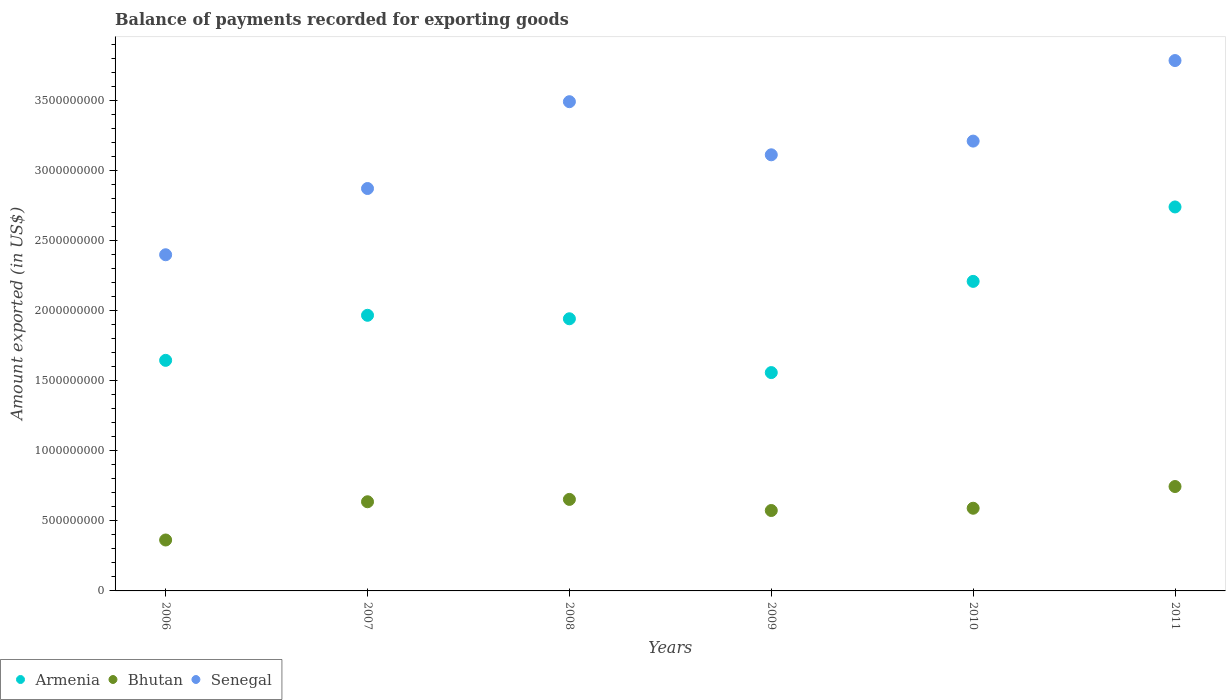How many different coloured dotlines are there?
Your answer should be very brief. 3. Is the number of dotlines equal to the number of legend labels?
Provide a short and direct response. Yes. What is the amount exported in Bhutan in 2011?
Offer a very short reply. 7.46e+08. Across all years, what is the maximum amount exported in Armenia?
Provide a succinct answer. 2.74e+09. Across all years, what is the minimum amount exported in Senegal?
Ensure brevity in your answer.  2.40e+09. What is the total amount exported in Senegal in the graph?
Offer a terse response. 1.89e+1. What is the difference between the amount exported in Bhutan in 2006 and that in 2010?
Keep it short and to the point. -2.27e+08. What is the difference between the amount exported in Senegal in 2009 and the amount exported in Armenia in 2010?
Your response must be concise. 9.04e+08. What is the average amount exported in Armenia per year?
Your response must be concise. 2.01e+09. In the year 2010, what is the difference between the amount exported in Senegal and amount exported in Bhutan?
Make the answer very short. 2.62e+09. What is the ratio of the amount exported in Bhutan in 2009 to that in 2010?
Your answer should be compact. 0.97. Is the difference between the amount exported in Senegal in 2010 and 2011 greater than the difference between the amount exported in Bhutan in 2010 and 2011?
Your answer should be very brief. No. What is the difference between the highest and the second highest amount exported in Bhutan?
Offer a very short reply. 9.19e+07. What is the difference between the highest and the lowest amount exported in Senegal?
Give a very brief answer. 1.39e+09. In how many years, is the amount exported in Bhutan greater than the average amount exported in Bhutan taken over all years?
Provide a succinct answer. 3. Is the sum of the amount exported in Armenia in 2007 and 2008 greater than the maximum amount exported in Senegal across all years?
Provide a succinct answer. Yes. Is the amount exported in Bhutan strictly greater than the amount exported in Senegal over the years?
Keep it short and to the point. No. Is the amount exported in Armenia strictly less than the amount exported in Senegal over the years?
Make the answer very short. Yes. How many dotlines are there?
Ensure brevity in your answer.  3. How many years are there in the graph?
Keep it short and to the point. 6. Does the graph contain any zero values?
Your answer should be very brief. No. Does the graph contain grids?
Your answer should be compact. No. Where does the legend appear in the graph?
Ensure brevity in your answer.  Bottom left. What is the title of the graph?
Keep it short and to the point. Balance of payments recorded for exporting goods. Does "Andorra" appear as one of the legend labels in the graph?
Your answer should be very brief. No. What is the label or title of the Y-axis?
Offer a very short reply. Amount exported (in US$). What is the Amount exported (in US$) of Armenia in 2006?
Ensure brevity in your answer.  1.65e+09. What is the Amount exported (in US$) in Bhutan in 2006?
Your answer should be compact. 3.64e+08. What is the Amount exported (in US$) of Senegal in 2006?
Your response must be concise. 2.40e+09. What is the Amount exported (in US$) of Armenia in 2007?
Make the answer very short. 1.97e+09. What is the Amount exported (in US$) in Bhutan in 2007?
Offer a very short reply. 6.37e+08. What is the Amount exported (in US$) of Senegal in 2007?
Ensure brevity in your answer.  2.87e+09. What is the Amount exported (in US$) of Armenia in 2008?
Your answer should be compact. 1.94e+09. What is the Amount exported (in US$) in Bhutan in 2008?
Ensure brevity in your answer.  6.54e+08. What is the Amount exported (in US$) in Senegal in 2008?
Your response must be concise. 3.49e+09. What is the Amount exported (in US$) of Armenia in 2009?
Provide a succinct answer. 1.56e+09. What is the Amount exported (in US$) in Bhutan in 2009?
Your response must be concise. 5.74e+08. What is the Amount exported (in US$) of Senegal in 2009?
Provide a succinct answer. 3.11e+09. What is the Amount exported (in US$) of Armenia in 2010?
Provide a short and direct response. 2.21e+09. What is the Amount exported (in US$) of Bhutan in 2010?
Your answer should be very brief. 5.90e+08. What is the Amount exported (in US$) in Senegal in 2010?
Keep it short and to the point. 3.21e+09. What is the Amount exported (in US$) in Armenia in 2011?
Give a very brief answer. 2.74e+09. What is the Amount exported (in US$) of Bhutan in 2011?
Offer a very short reply. 7.46e+08. What is the Amount exported (in US$) in Senegal in 2011?
Your response must be concise. 3.79e+09. Across all years, what is the maximum Amount exported (in US$) in Armenia?
Give a very brief answer. 2.74e+09. Across all years, what is the maximum Amount exported (in US$) of Bhutan?
Ensure brevity in your answer.  7.46e+08. Across all years, what is the maximum Amount exported (in US$) in Senegal?
Your answer should be compact. 3.79e+09. Across all years, what is the minimum Amount exported (in US$) in Armenia?
Keep it short and to the point. 1.56e+09. Across all years, what is the minimum Amount exported (in US$) of Bhutan?
Your answer should be very brief. 3.64e+08. Across all years, what is the minimum Amount exported (in US$) in Senegal?
Your response must be concise. 2.40e+09. What is the total Amount exported (in US$) of Armenia in the graph?
Provide a short and direct response. 1.21e+1. What is the total Amount exported (in US$) in Bhutan in the graph?
Provide a succinct answer. 3.56e+09. What is the total Amount exported (in US$) of Senegal in the graph?
Ensure brevity in your answer.  1.89e+1. What is the difference between the Amount exported (in US$) of Armenia in 2006 and that in 2007?
Offer a terse response. -3.22e+08. What is the difference between the Amount exported (in US$) of Bhutan in 2006 and that in 2007?
Provide a succinct answer. -2.73e+08. What is the difference between the Amount exported (in US$) in Senegal in 2006 and that in 2007?
Offer a very short reply. -4.73e+08. What is the difference between the Amount exported (in US$) of Armenia in 2006 and that in 2008?
Provide a succinct answer. -2.97e+08. What is the difference between the Amount exported (in US$) of Bhutan in 2006 and that in 2008?
Ensure brevity in your answer.  -2.90e+08. What is the difference between the Amount exported (in US$) in Senegal in 2006 and that in 2008?
Provide a short and direct response. -1.09e+09. What is the difference between the Amount exported (in US$) of Armenia in 2006 and that in 2009?
Your answer should be very brief. 8.74e+07. What is the difference between the Amount exported (in US$) of Bhutan in 2006 and that in 2009?
Offer a terse response. -2.11e+08. What is the difference between the Amount exported (in US$) in Senegal in 2006 and that in 2009?
Your answer should be very brief. -7.14e+08. What is the difference between the Amount exported (in US$) of Armenia in 2006 and that in 2010?
Your answer should be very brief. -5.64e+08. What is the difference between the Amount exported (in US$) in Bhutan in 2006 and that in 2010?
Make the answer very short. -2.27e+08. What is the difference between the Amount exported (in US$) of Senegal in 2006 and that in 2010?
Your answer should be very brief. -8.12e+08. What is the difference between the Amount exported (in US$) of Armenia in 2006 and that in 2011?
Your answer should be very brief. -1.10e+09. What is the difference between the Amount exported (in US$) of Bhutan in 2006 and that in 2011?
Give a very brief answer. -3.82e+08. What is the difference between the Amount exported (in US$) in Senegal in 2006 and that in 2011?
Your answer should be very brief. -1.39e+09. What is the difference between the Amount exported (in US$) in Armenia in 2007 and that in 2008?
Your answer should be very brief. 2.48e+07. What is the difference between the Amount exported (in US$) of Bhutan in 2007 and that in 2008?
Make the answer very short. -1.69e+07. What is the difference between the Amount exported (in US$) in Senegal in 2007 and that in 2008?
Your answer should be very brief. -6.20e+08. What is the difference between the Amount exported (in US$) in Armenia in 2007 and that in 2009?
Offer a terse response. 4.09e+08. What is the difference between the Amount exported (in US$) in Bhutan in 2007 and that in 2009?
Your response must be concise. 6.25e+07. What is the difference between the Amount exported (in US$) in Senegal in 2007 and that in 2009?
Give a very brief answer. -2.41e+08. What is the difference between the Amount exported (in US$) in Armenia in 2007 and that in 2010?
Your response must be concise. -2.42e+08. What is the difference between the Amount exported (in US$) of Bhutan in 2007 and that in 2010?
Your answer should be compact. 4.63e+07. What is the difference between the Amount exported (in US$) of Senegal in 2007 and that in 2010?
Offer a terse response. -3.39e+08. What is the difference between the Amount exported (in US$) of Armenia in 2007 and that in 2011?
Provide a succinct answer. -7.74e+08. What is the difference between the Amount exported (in US$) of Bhutan in 2007 and that in 2011?
Keep it short and to the point. -1.09e+08. What is the difference between the Amount exported (in US$) in Senegal in 2007 and that in 2011?
Provide a succinct answer. -9.14e+08. What is the difference between the Amount exported (in US$) of Armenia in 2008 and that in 2009?
Make the answer very short. 3.84e+08. What is the difference between the Amount exported (in US$) in Bhutan in 2008 and that in 2009?
Your answer should be very brief. 7.94e+07. What is the difference between the Amount exported (in US$) of Senegal in 2008 and that in 2009?
Make the answer very short. 3.79e+08. What is the difference between the Amount exported (in US$) in Armenia in 2008 and that in 2010?
Provide a short and direct response. -2.67e+08. What is the difference between the Amount exported (in US$) of Bhutan in 2008 and that in 2010?
Give a very brief answer. 6.32e+07. What is the difference between the Amount exported (in US$) of Senegal in 2008 and that in 2010?
Make the answer very short. 2.81e+08. What is the difference between the Amount exported (in US$) in Armenia in 2008 and that in 2011?
Provide a succinct answer. -7.99e+08. What is the difference between the Amount exported (in US$) in Bhutan in 2008 and that in 2011?
Provide a short and direct response. -9.19e+07. What is the difference between the Amount exported (in US$) of Senegal in 2008 and that in 2011?
Your response must be concise. -2.94e+08. What is the difference between the Amount exported (in US$) in Armenia in 2009 and that in 2010?
Offer a terse response. -6.51e+08. What is the difference between the Amount exported (in US$) of Bhutan in 2009 and that in 2010?
Your answer should be very brief. -1.62e+07. What is the difference between the Amount exported (in US$) of Senegal in 2009 and that in 2010?
Offer a terse response. -9.78e+07. What is the difference between the Amount exported (in US$) in Armenia in 2009 and that in 2011?
Give a very brief answer. -1.18e+09. What is the difference between the Amount exported (in US$) in Bhutan in 2009 and that in 2011?
Provide a succinct answer. -1.71e+08. What is the difference between the Amount exported (in US$) in Senegal in 2009 and that in 2011?
Ensure brevity in your answer.  -6.73e+08. What is the difference between the Amount exported (in US$) of Armenia in 2010 and that in 2011?
Ensure brevity in your answer.  -5.32e+08. What is the difference between the Amount exported (in US$) in Bhutan in 2010 and that in 2011?
Offer a terse response. -1.55e+08. What is the difference between the Amount exported (in US$) of Senegal in 2010 and that in 2011?
Offer a terse response. -5.75e+08. What is the difference between the Amount exported (in US$) of Armenia in 2006 and the Amount exported (in US$) of Bhutan in 2007?
Provide a succinct answer. 1.01e+09. What is the difference between the Amount exported (in US$) in Armenia in 2006 and the Amount exported (in US$) in Senegal in 2007?
Offer a terse response. -1.23e+09. What is the difference between the Amount exported (in US$) in Bhutan in 2006 and the Amount exported (in US$) in Senegal in 2007?
Give a very brief answer. -2.51e+09. What is the difference between the Amount exported (in US$) of Armenia in 2006 and the Amount exported (in US$) of Bhutan in 2008?
Keep it short and to the point. 9.93e+08. What is the difference between the Amount exported (in US$) in Armenia in 2006 and the Amount exported (in US$) in Senegal in 2008?
Your answer should be very brief. -1.85e+09. What is the difference between the Amount exported (in US$) of Bhutan in 2006 and the Amount exported (in US$) of Senegal in 2008?
Provide a succinct answer. -3.13e+09. What is the difference between the Amount exported (in US$) in Armenia in 2006 and the Amount exported (in US$) in Bhutan in 2009?
Offer a very short reply. 1.07e+09. What is the difference between the Amount exported (in US$) of Armenia in 2006 and the Amount exported (in US$) of Senegal in 2009?
Keep it short and to the point. -1.47e+09. What is the difference between the Amount exported (in US$) of Bhutan in 2006 and the Amount exported (in US$) of Senegal in 2009?
Your answer should be compact. -2.75e+09. What is the difference between the Amount exported (in US$) of Armenia in 2006 and the Amount exported (in US$) of Bhutan in 2010?
Make the answer very short. 1.06e+09. What is the difference between the Amount exported (in US$) in Armenia in 2006 and the Amount exported (in US$) in Senegal in 2010?
Provide a succinct answer. -1.57e+09. What is the difference between the Amount exported (in US$) of Bhutan in 2006 and the Amount exported (in US$) of Senegal in 2010?
Keep it short and to the point. -2.85e+09. What is the difference between the Amount exported (in US$) in Armenia in 2006 and the Amount exported (in US$) in Bhutan in 2011?
Your answer should be very brief. 9.01e+08. What is the difference between the Amount exported (in US$) in Armenia in 2006 and the Amount exported (in US$) in Senegal in 2011?
Ensure brevity in your answer.  -2.14e+09. What is the difference between the Amount exported (in US$) of Bhutan in 2006 and the Amount exported (in US$) of Senegal in 2011?
Provide a succinct answer. -3.42e+09. What is the difference between the Amount exported (in US$) of Armenia in 2007 and the Amount exported (in US$) of Bhutan in 2008?
Your answer should be compact. 1.31e+09. What is the difference between the Amount exported (in US$) in Armenia in 2007 and the Amount exported (in US$) in Senegal in 2008?
Provide a succinct answer. -1.53e+09. What is the difference between the Amount exported (in US$) of Bhutan in 2007 and the Amount exported (in US$) of Senegal in 2008?
Keep it short and to the point. -2.86e+09. What is the difference between the Amount exported (in US$) in Armenia in 2007 and the Amount exported (in US$) in Bhutan in 2009?
Keep it short and to the point. 1.39e+09. What is the difference between the Amount exported (in US$) in Armenia in 2007 and the Amount exported (in US$) in Senegal in 2009?
Your answer should be very brief. -1.15e+09. What is the difference between the Amount exported (in US$) in Bhutan in 2007 and the Amount exported (in US$) in Senegal in 2009?
Give a very brief answer. -2.48e+09. What is the difference between the Amount exported (in US$) of Armenia in 2007 and the Amount exported (in US$) of Bhutan in 2010?
Your answer should be compact. 1.38e+09. What is the difference between the Amount exported (in US$) in Armenia in 2007 and the Amount exported (in US$) in Senegal in 2010?
Your answer should be very brief. -1.24e+09. What is the difference between the Amount exported (in US$) in Bhutan in 2007 and the Amount exported (in US$) in Senegal in 2010?
Give a very brief answer. -2.58e+09. What is the difference between the Amount exported (in US$) of Armenia in 2007 and the Amount exported (in US$) of Bhutan in 2011?
Offer a terse response. 1.22e+09. What is the difference between the Amount exported (in US$) of Armenia in 2007 and the Amount exported (in US$) of Senegal in 2011?
Make the answer very short. -1.82e+09. What is the difference between the Amount exported (in US$) in Bhutan in 2007 and the Amount exported (in US$) in Senegal in 2011?
Your response must be concise. -3.15e+09. What is the difference between the Amount exported (in US$) of Armenia in 2008 and the Amount exported (in US$) of Bhutan in 2009?
Make the answer very short. 1.37e+09. What is the difference between the Amount exported (in US$) in Armenia in 2008 and the Amount exported (in US$) in Senegal in 2009?
Provide a succinct answer. -1.17e+09. What is the difference between the Amount exported (in US$) of Bhutan in 2008 and the Amount exported (in US$) of Senegal in 2009?
Your answer should be compact. -2.46e+09. What is the difference between the Amount exported (in US$) in Armenia in 2008 and the Amount exported (in US$) in Bhutan in 2010?
Your answer should be compact. 1.35e+09. What is the difference between the Amount exported (in US$) in Armenia in 2008 and the Amount exported (in US$) in Senegal in 2010?
Your answer should be very brief. -1.27e+09. What is the difference between the Amount exported (in US$) in Bhutan in 2008 and the Amount exported (in US$) in Senegal in 2010?
Provide a succinct answer. -2.56e+09. What is the difference between the Amount exported (in US$) of Armenia in 2008 and the Amount exported (in US$) of Bhutan in 2011?
Offer a terse response. 1.20e+09. What is the difference between the Amount exported (in US$) of Armenia in 2008 and the Amount exported (in US$) of Senegal in 2011?
Your answer should be very brief. -1.84e+09. What is the difference between the Amount exported (in US$) in Bhutan in 2008 and the Amount exported (in US$) in Senegal in 2011?
Give a very brief answer. -3.13e+09. What is the difference between the Amount exported (in US$) of Armenia in 2009 and the Amount exported (in US$) of Bhutan in 2010?
Give a very brief answer. 9.69e+08. What is the difference between the Amount exported (in US$) of Armenia in 2009 and the Amount exported (in US$) of Senegal in 2010?
Make the answer very short. -1.65e+09. What is the difference between the Amount exported (in US$) in Bhutan in 2009 and the Amount exported (in US$) in Senegal in 2010?
Your answer should be compact. -2.64e+09. What is the difference between the Amount exported (in US$) of Armenia in 2009 and the Amount exported (in US$) of Bhutan in 2011?
Your answer should be very brief. 8.14e+08. What is the difference between the Amount exported (in US$) of Armenia in 2009 and the Amount exported (in US$) of Senegal in 2011?
Keep it short and to the point. -2.23e+09. What is the difference between the Amount exported (in US$) in Bhutan in 2009 and the Amount exported (in US$) in Senegal in 2011?
Keep it short and to the point. -3.21e+09. What is the difference between the Amount exported (in US$) of Armenia in 2010 and the Amount exported (in US$) of Bhutan in 2011?
Your answer should be very brief. 1.47e+09. What is the difference between the Amount exported (in US$) in Armenia in 2010 and the Amount exported (in US$) in Senegal in 2011?
Your answer should be very brief. -1.58e+09. What is the difference between the Amount exported (in US$) in Bhutan in 2010 and the Amount exported (in US$) in Senegal in 2011?
Ensure brevity in your answer.  -3.20e+09. What is the average Amount exported (in US$) of Armenia per year?
Ensure brevity in your answer.  2.01e+09. What is the average Amount exported (in US$) in Bhutan per year?
Ensure brevity in your answer.  5.94e+08. What is the average Amount exported (in US$) in Senegal per year?
Your response must be concise. 3.15e+09. In the year 2006, what is the difference between the Amount exported (in US$) of Armenia and Amount exported (in US$) of Bhutan?
Make the answer very short. 1.28e+09. In the year 2006, what is the difference between the Amount exported (in US$) of Armenia and Amount exported (in US$) of Senegal?
Provide a succinct answer. -7.54e+08. In the year 2006, what is the difference between the Amount exported (in US$) in Bhutan and Amount exported (in US$) in Senegal?
Make the answer very short. -2.04e+09. In the year 2007, what is the difference between the Amount exported (in US$) in Armenia and Amount exported (in US$) in Bhutan?
Offer a very short reply. 1.33e+09. In the year 2007, what is the difference between the Amount exported (in US$) of Armenia and Amount exported (in US$) of Senegal?
Make the answer very short. -9.05e+08. In the year 2007, what is the difference between the Amount exported (in US$) of Bhutan and Amount exported (in US$) of Senegal?
Offer a terse response. -2.24e+09. In the year 2008, what is the difference between the Amount exported (in US$) in Armenia and Amount exported (in US$) in Bhutan?
Ensure brevity in your answer.  1.29e+09. In the year 2008, what is the difference between the Amount exported (in US$) in Armenia and Amount exported (in US$) in Senegal?
Keep it short and to the point. -1.55e+09. In the year 2008, what is the difference between the Amount exported (in US$) in Bhutan and Amount exported (in US$) in Senegal?
Give a very brief answer. -2.84e+09. In the year 2009, what is the difference between the Amount exported (in US$) of Armenia and Amount exported (in US$) of Bhutan?
Your answer should be compact. 9.85e+08. In the year 2009, what is the difference between the Amount exported (in US$) in Armenia and Amount exported (in US$) in Senegal?
Provide a short and direct response. -1.56e+09. In the year 2009, what is the difference between the Amount exported (in US$) of Bhutan and Amount exported (in US$) of Senegal?
Provide a short and direct response. -2.54e+09. In the year 2010, what is the difference between the Amount exported (in US$) in Armenia and Amount exported (in US$) in Bhutan?
Your response must be concise. 1.62e+09. In the year 2010, what is the difference between the Amount exported (in US$) in Armenia and Amount exported (in US$) in Senegal?
Your answer should be very brief. -1.00e+09. In the year 2010, what is the difference between the Amount exported (in US$) of Bhutan and Amount exported (in US$) of Senegal?
Offer a terse response. -2.62e+09. In the year 2011, what is the difference between the Amount exported (in US$) in Armenia and Amount exported (in US$) in Bhutan?
Your answer should be compact. 2.00e+09. In the year 2011, what is the difference between the Amount exported (in US$) of Armenia and Amount exported (in US$) of Senegal?
Your answer should be very brief. -1.05e+09. In the year 2011, what is the difference between the Amount exported (in US$) of Bhutan and Amount exported (in US$) of Senegal?
Your answer should be very brief. -3.04e+09. What is the ratio of the Amount exported (in US$) in Armenia in 2006 to that in 2007?
Offer a terse response. 0.84. What is the ratio of the Amount exported (in US$) in Bhutan in 2006 to that in 2007?
Give a very brief answer. 0.57. What is the ratio of the Amount exported (in US$) in Senegal in 2006 to that in 2007?
Give a very brief answer. 0.84. What is the ratio of the Amount exported (in US$) of Armenia in 2006 to that in 2008?
Keep it short and to the point. 0.85. What is the ratio of the Amount exported (in US$) in Bhutan in 2006 to that in 2008?
Give a very brief answer. 0.56. What is the ratio of the Amount exported (in US$) in Senegal in 2006 to that in 2008?
Your response must be concise. 0.69. What is the ratio of the Amount exported (in US$) in Armenia in 2006 to that in 2009?
Your answer should be very brief. 1.06. What is the ratio of the Amount exported (in US$) of Bhutan in 2006 to that in 2009?
Your response must be concise. 0.63. What is the ratio of the Amount exported (in US$) of Senegal in 2006 to that in 2009?
Give a very brief answer. 0.77. What is the ratio of the Amount exported (in US$) in Armenia in 2006 to that in 2010?
Ensure brevity in your answer.  0.74. What is the ratio of the Amount exported (in US$) of Bhutan in 2006 to that in 2010?
Offer a very short reply. 0.62. What is the ratio of the Amount exported (in US$) in Senegal in 2006 to that in 2010?
Offer a terse response. 0.75. What is the ratio of the Amount exported (in US$) in Armenia in 2006 to that in 2011?
Keep it short and to the point. 0.6. What is the ratio of the Amount exported (in US$) in Bhutan in 2006 to that in 2011?
Your answer should be compact. 0.49. What is the ratio of the Amount exported (in US$) of Senegal in 2006 to that in 2011?
Keep it short and to the point. 0.63. What is the ratio of the Amount exported (in US$) in Armenia in 2007 to that in 2008?
Your response must be concise. 1.01. What is the ratio of the Amount exported (in US$) in Bhutan in 2007 to that in 2008?
Offer a terse response. 0.97. What is the ratio of the Amount exported (in US$) of Senegal in 2007 to that in 2008?
Make the answer very short. 0.82. What is the ratio of the Amount exported (in US$) in Armenia in 2007 to that in 2009?
Ensure brevity in your answer.  1.26. What is the ratio of the Amount exported (in US$) in Bhutan in 2007 to that in 2009?
Offer a very short reply. 1.11. What is the ratio of the Amount exported (in US$) of Senegal in 2007 to that in 2009?
Your answer should be compact. 0.92. What is the ratio of the Amount exported (in US$) in Armenia in 2007 to that in 2010?
Provide a short and direct response. 0.89. What is the ratio of the Amount exported (in US$) of Bhutan in 2007 to that in 2010?
Offer a very short reply. 1.08. What is the ratio of the Amount exported (in US$) in Senegal in 2007 to that in 2010?
Ensure brevity in your answer.  0.89. What is the ratio of the Amount exported (in US$) in Armenia in 2007 to that in 2011?
Offer a terse response. 0.72. What is the ratio of the Amount exported (in US$) in Bhutan in 2007 to that in 2011?
Make the answer very short. 0.85. What is the ratio of the Amount exported (in US$) in Senegal in 2007 to that in 2011?
Offer a very short reply. 0.76. What is the ratio of the Amount exported (in US$) of Armenia in 2008 to that in 2009?
Give a very brief answer. 1.25. What is the ratio of the Amount exported (in US$) of Bhutan in 2008 to that in 2009?
Provide a succinct answer. 1.14. What is the ratio of the Amount exported (in US$) of Senegal in 2008 to that in 2009?
Your answer should be compact. 1.12. What is the ratio of the Amount exported (in US$) of Armenia in 2008 to that in 2010?
Ensure brevity in your answer.  0.88. What is the ratio of the Amount exported (in US$) of Bhutan in 2008 to that in 2010?
Your response must be concise. 1.11. What is the ratio of the Amount exported (in US$) of Senegal in 2008 to that in 2010?
Ensure brevity in your answer.  1.09. What is the ratio of the Amount exported (in US$) in Armenia in 2008 to that in 2011?
Give a very brief answer. 0.71. What is the ratio of the Amount exported (in US$) in Bhutan in 2008 to that in 2011?
Your answer should be very brief. 0.88. What is the ratio of the Amount exported (in US$) in Senegal in 2008 to that in 2011?
Provide a succinct answer. 0.92. What is the ratio of the Amount exported (in US$) of Armenia in 2009 to that in 2010?
Your response must be concise. 0.71. What is the ratio of the Amount exported (in US$) of Bhutan in 2009 to that in 2010?
Ensure brevity in your answer.  0.97. What is the ratio of the Amount exported (in US$) in Senegal in 2009 to that in 2010?
Provide a succinct answer. 0.97. What is the ratio of the Amount exported (in US$) of Armenia in 2009 to that in 2011?
Your answer should be very brief. 0.57. What is the ratio of the Amount exported (in US$) of Bhutan in 2009 to that in 2011?
Give a very brief answer. 0.77. What is the ratio of the Amount exported (in US$) in Senegal in 2009 to that in 2011?
Ensure brevity in your answer.  0.82. What is the ratio of the Amount exported (in US$) in Armenia in 2010 to that in 2011?
Offer a terse response. 0.81. What is the ratio of the Amount exported (in US$) of Bhutan in 2010 to that in 2011?
Your answer should be very brief. 0.79. What is the ratio of the Amount exported (in US$) in Senegal in 2010 to that in 2011?
Ensure brevity in your answer.  0.85. What is the difference between the highest and the second highest Amount exported (in US$) in Armenia?
Give a very brief answer. 5.32e+08. What is the difference between the highest and the second highest Amount exported (in US$) of Bhutan?
Your answer should be very brief. 9.19e+07. What is the difference between the highest and the second highest Amount exported (in US$) of Senegal?
Your response must be concise. 2.94e+08. What is the difference between the highest and the lowest Amount exported (in US$) of Armenia?
Your answer should be compact. 1.18e+09. What is the difference between the highest and the lowest Amount exported (in US$) of Bhutan?
Keep it short and to the point. 3.82e+08. What is the difference between the highest and the lowest Amount exported (in US$) in Senegal?
Your response must be concise. 1.39e+09. 